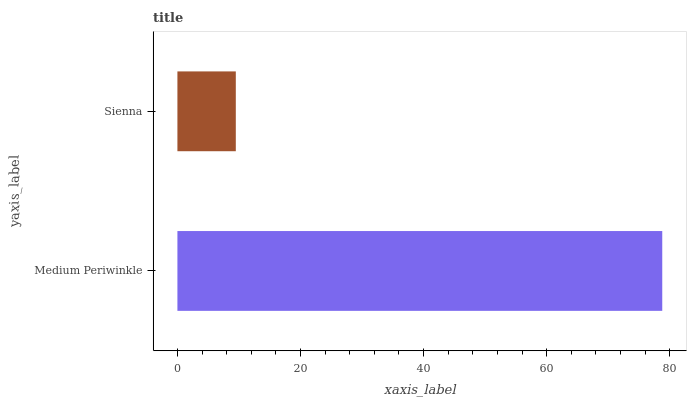Is Sienna the minimum?
Answer yes or no. Yes. Is Medium Periwinkle the maximum?
Answer yes or no. Yes. Is Sienna the maximum?
Answer yes or no. No. Is Medium Periwinkle greater than Sienna?
Answer yes or no. Yes. Is Sienna less than Medium Periwinkle?
Answer yes or no. Yes. Is Sienna greater than Medium Periwinkle?
Answer yes or no. No. Is Medium Periwinkle less than Sienna?
Answer yes or no. No. Is Medium Periwinkle the high median?
Answer yes or no. Yes. Is Sienna the low median?
Answer yes or no. Yes. Is Sienna the high median?
Answer yes or no. No. Is Medium Periwinkle the low median?
Answer yes or no. No. 